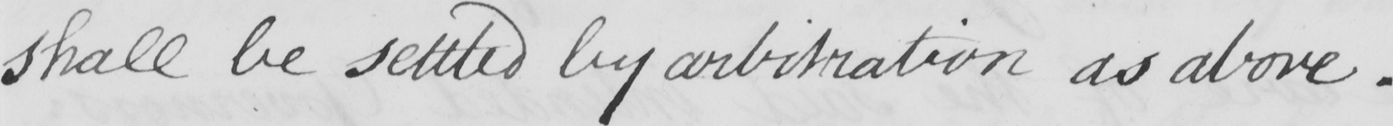What text is written in this handwritten line? shall be settled by arbitration as above . 